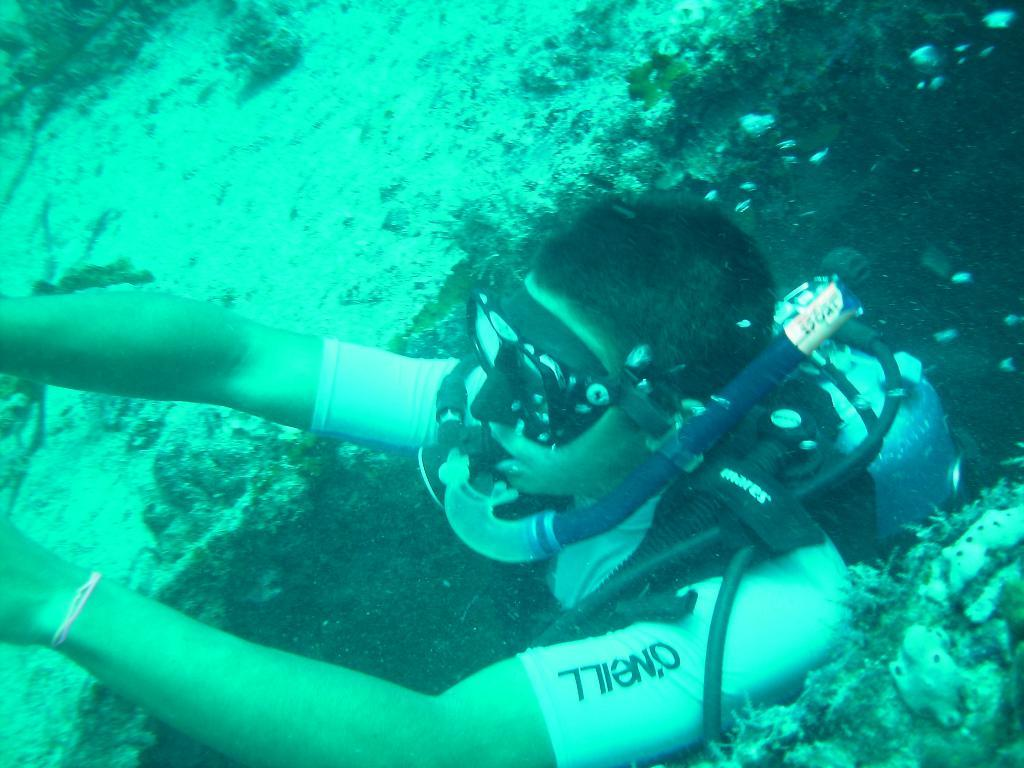What is the setting of the image? The image is taken underwater. Who is present in the image? There is a man in the image. What equipment is the man wearing? The man is wearing a diving mask and an oxygen cylinder. What else can be seen in the image besides the man? There are marine creatures in the image. What type of steel is used to construct the glove in the image? There is no glove present in the image; the man is wearing a diving mask and an oxygen cylinder. 